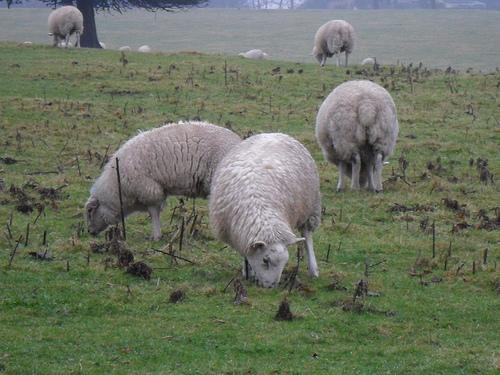Describe the setting of the image. The image takes place in a vast grassy field with a hill beyond it, a tree in the field, and dead plants scattered around. Describe the location where the image might have been captured. The image seems to be taken at a farm or prairie, with a large grass field, a tree, and a hill in the background. Mention the main animals in the image and their primary activity. The main animals are five white sheep, feeding and grazing on the grass in the field. Mention the color of the grass in the image and what the animals are doing. The grass is green, and the sheep are feeding and grazing on it. Name the animals present in the image and what they are focused on. Sheep are the main animals, and they are focused on eating grass. In a few words, tell us what's happening in the image. Five sheep are grazing in a large grassy field, with a tree and hill in the background. Identify the primary focus of the picture and what the subjects are engaged in. The main focus is on five sheep in the grass field, grazing and feeding on the green grass around a tree. What is the main subject of the image, and what is its background setting? The main subject is a flock of sheep grazing, and the background setting is a large green grass field, with a tree and hill. What type of scene is depicted in the image? It is an outdoor daytime scene with sheep grazing in a green grass field. Provide a brief summary of the scene in the image. A flock of sheep are grazing and walking around in a large green field with a tree, hill, and dead plants visible in the background. 